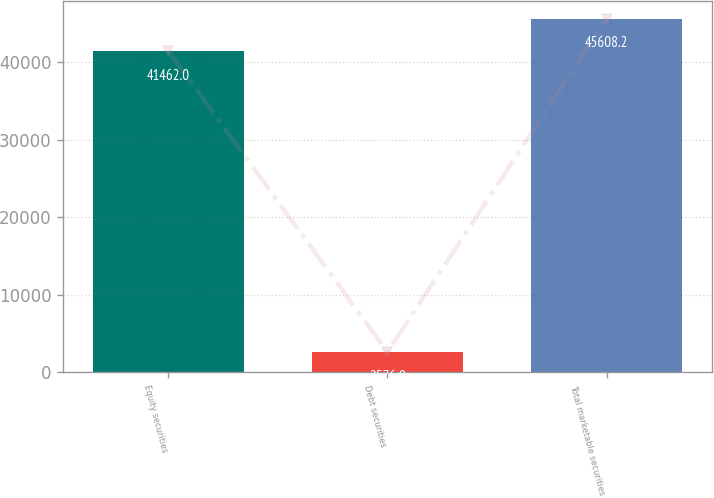Convert chart to OTSL. <chart><loc_0><loc_0><loc_500><loc_500><bar_chart><fcel>Equity securities<fcel>Debt securities<fcel>Total marketable securities<nl><fcel>41462<fcel>2576<fcel>45608.2<nl></chart> 